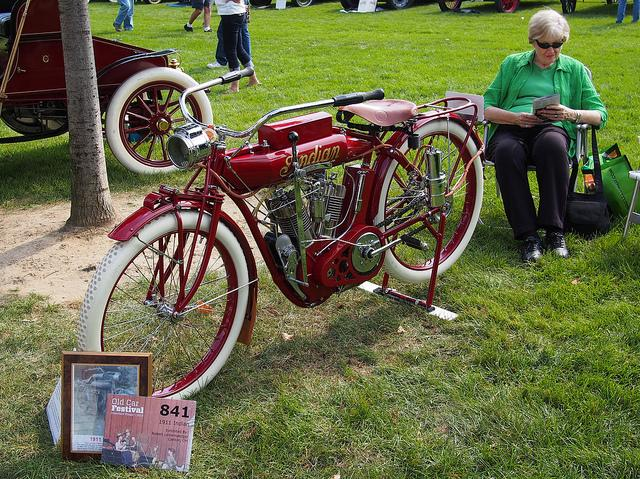For what purpose is this bike being exhibited?

Choices:
A) sale
B) no reason
C) parked temporarily
D) display only display only 